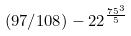Convert formula to latex. <formula><loc_0><loc_0><loc_500><loc_500>( 9 7 / 1 0 8 ) - 2 2 ^ { \frac { 7 5 ^ { 3 } } { 5 } }</formula> 